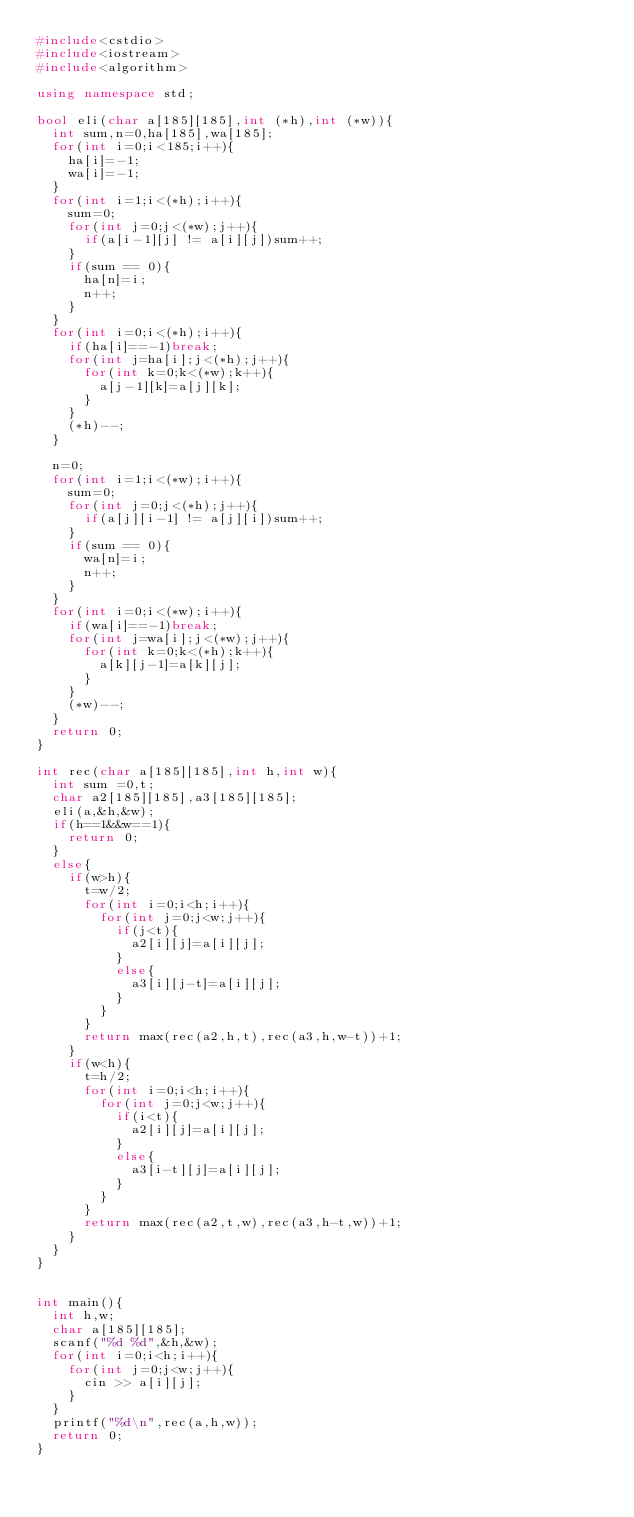<code> <loc_0><loc_0><loc_500><loc_500><_C++_>#include<cstdio>
#include<iostream>
#include<algorithm>

using namespace std;

bool eli(char a[185][185],int (*h),int (*w)){
	int sum,n=0,ha[185],wa[185];
	for(int i=0;i<185;i++){
		ha[i]=-1;
		wa[i]=-1;
	}
	for(int i=1;i<(*h);i++){
		sum=0;
		for(int j=0;j<(*w);j++){
			if(a[i-1][j] != a[i][j])sum++;
		}
		if(sum == 0){
			ha[n]=i;
			n++;
		}
	}
	for(int i=0;i<(*h);i++){
		if(ha[i]==-1)break;
		for(int j=ha[i];j<(*h);j++){
			for(int k=0;k<(*w);k++){
				a[j-1][k]=a[j][k];
			}
		}
		(*h)--;
	}
			
	n=0;
	for(int i=1;i<(*w);i++){
		sum=0;
		for(int j=0;j<(*h);j++){
			if(a[j][i-1] != a[j][i])sum++;
		}
		if(sum == 0){
			wa[n]=i;
			n++;
		}
	}
	for(int i=0;i<(*w);i++){
		if(wa[i]==-1)break;
		for(int j=wa[i];j<(*w);j++){
			for(int k=0;k<(*h);k++){
				a[k][j-1]=a[k][j];
			}
		}
		(*w)--;
	}
	return 0;
}

int rec(char a[185][185],int h,int w){
	int sum =0,t;
	char a2[185][185],a3[185][185];
	eli(a,&h,&w);
	if(h==1&&w==1){
		return 0;
	}
	else{
		if(w>h){
			t=w/2;
			for(int i=0;i<h;i++){
				for(int j=0;j<w;j++){
					if(j<t){
						a2[i][j]=a[i][j];
					}
					else{
						a3[i][j-t]=a[i][j];
					}
				}
			}
			return max(rec(a2,h,t),rec(a3,h,w-t))+1;
		}
		if(w<h){
			t=h/2;
			for(int i=0;i<h;i++){
				for(int j=0;j<w;j++){
					if(i<t){
						a2[i][j]=a[i][j];
					}
					else{
						a3[i-t][j]=a[i][j];
					}
				}
			}
			return max(rec(a2,t,w),rec(a3,h-t,w))+1;
		}
	}
}
	

int main(){
	int h,w;
	char a[185][185];
	scanf("%d %d",&h,&w);
	for(int i=0;i<h;i++){
		for(int j=0;j<w;j++){
			cin >> a[i][j];
		}
	}
	printf("%d\n",rec(a,h,w));
	return 0;
}
</code> 